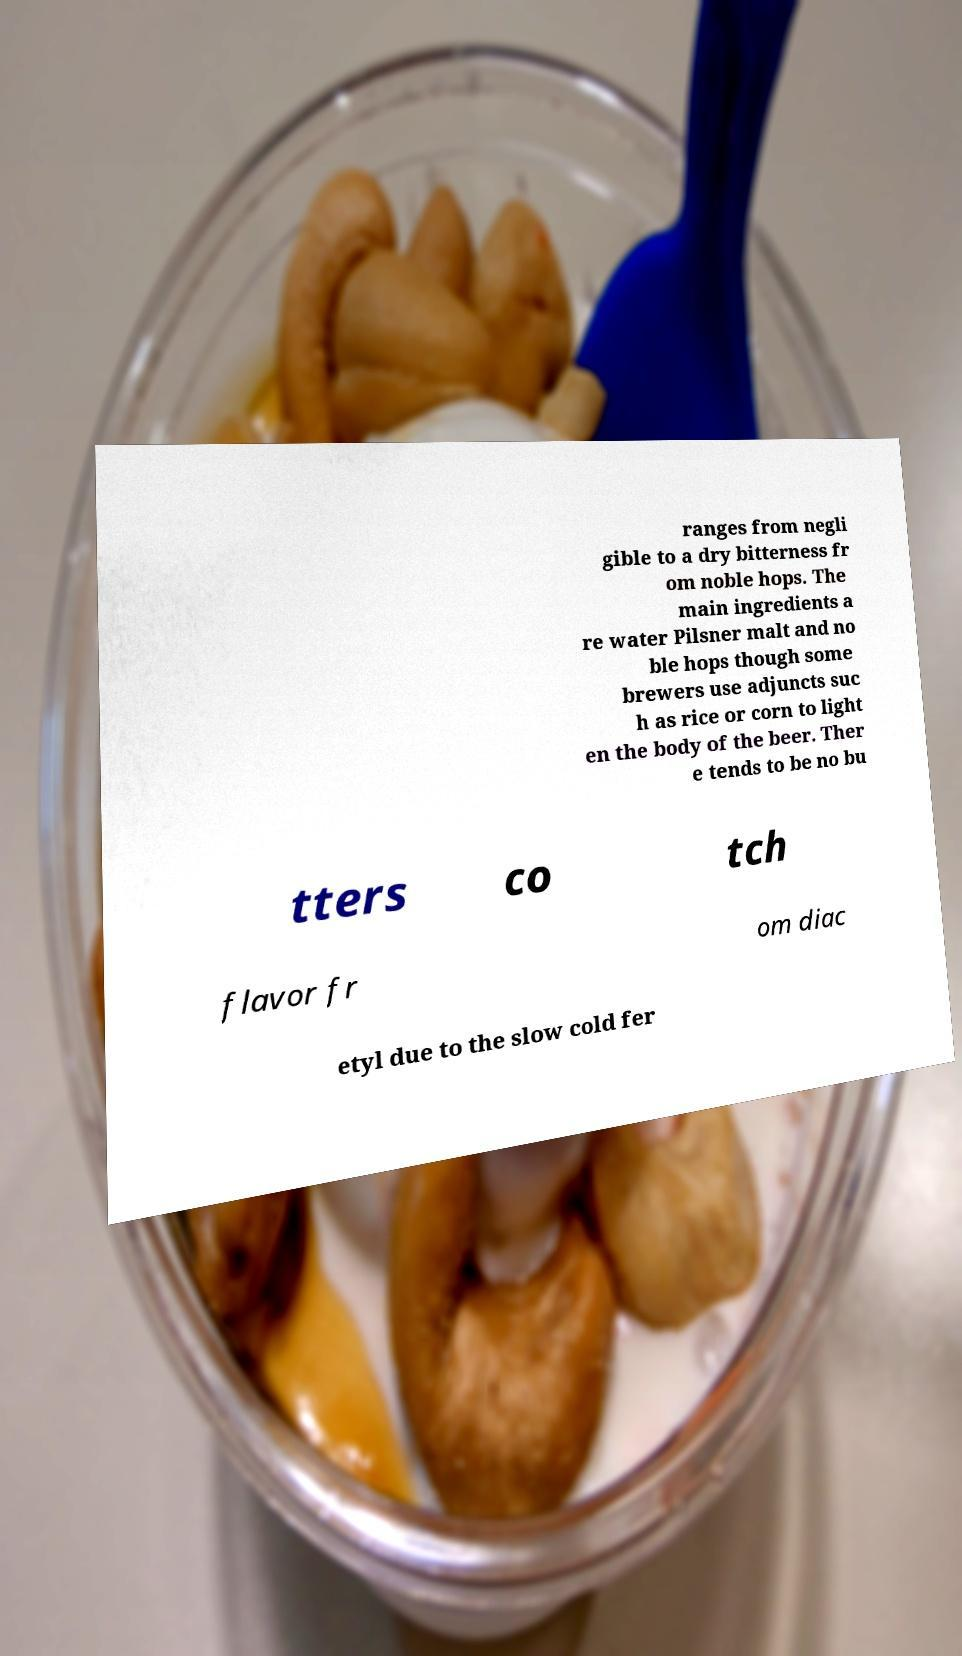Could you assist in decoding the text presented in this image and type it out clearly? ranges from negli gible to a dry bitterness fr om noble hops. The main ingredients a re water Pilsner malt and no ble hops though some brewers use adjuncts suc h as rice or corn to light en the body of the beer. Ther e tends to be no bu tters co tch flavor fr om diac etyl due to the slow cold fer 